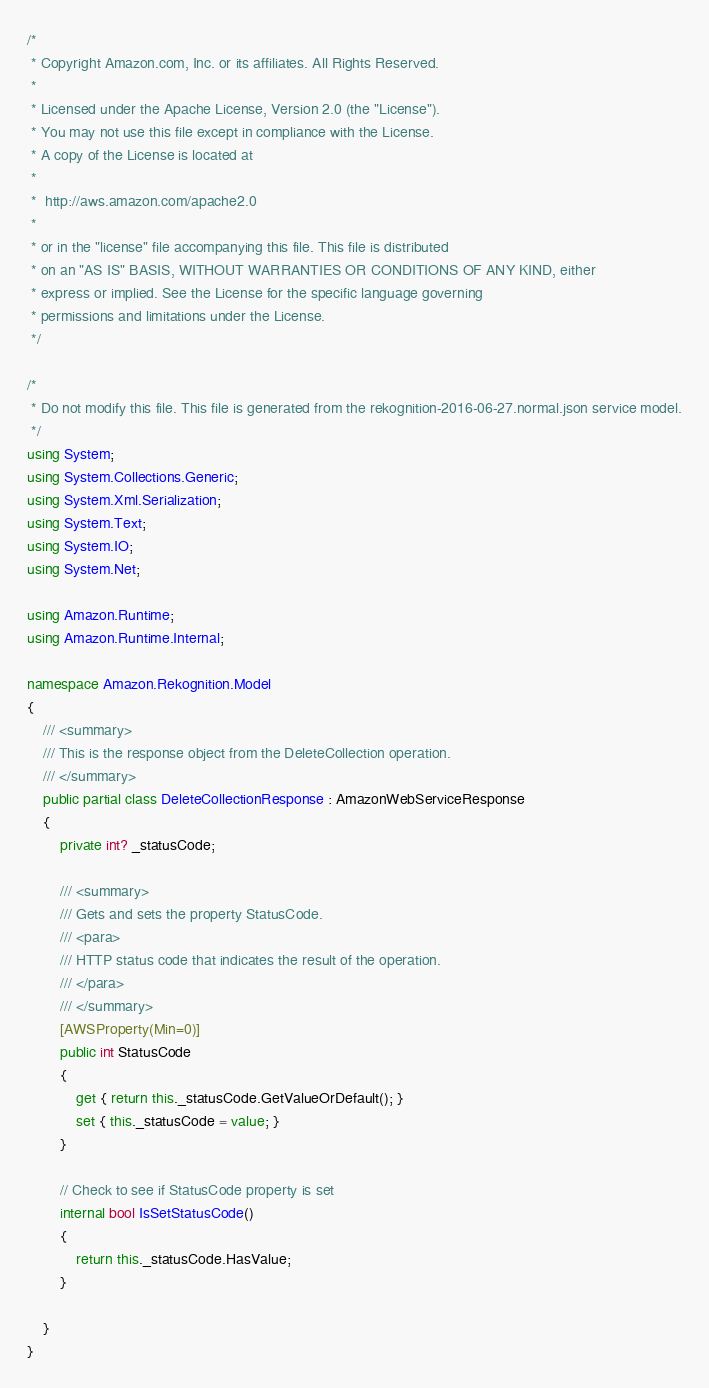Convert code to text. <code><loc_0><loc_0><loc_500><loc_500><_C#_>/*
 * Copyright Amazon.com, Inc. or its affiliates. All Rights Reserved.
 * 
 * Licensed under the Apache License, Version 2.0 (the "License").
 * You may not use this file except in compliance with the License.
 * A copy of the License is located at
 * 
 *  http://aws.amazon.com/apache2.0
 * 
 * or in the "license" file accompanying this file. This file is distributed
 * on an "AS IS" BASIS, WITHOUT WARRANTIES OR CONDITIONS OF ANY KIND, either
 * express or implied. See the License for the specific language governing
 * permissions and limitations under the License.
 */

/*
 * Do not modify this file. This file is generated from the rekognition-2016-06-27.normal.json service model.
 */
using System;
using System.Collections.Generic;
using System.Xml.Serialization;
using System.Text;
using System.IO;
using System.Net;

using Amazon.Runtime;
using Amazon.Runtime.Internal;

namespace Amazon.Rekognition.Model
{
    /// <summary>
    /// This is the response object from the DeleteCollection operation.
    /// </summary>
    public partial class DeleteCollectionResponse : AmazonWebServiceResponse
    {
        private int? _statusCode;

        /// <summary>
        /// Gets and sets the property StatusCode. 
        /// <para>
        /// HTTP status code that indicates the result of the operation.
        /// </para>
        /// </summary>
        [AWSProperty(Min=0)]
        public int StatusCode
        {
            get { return this._statusCode.GetValueOrDefault(); }
            set { this._statusCode = value; }
        }

        // Check to see if StatusCode property is set
        internal bool IsSetStatusCode()
        {
            return this._statusCode.HasValue; 
        }

    }
}</code> 